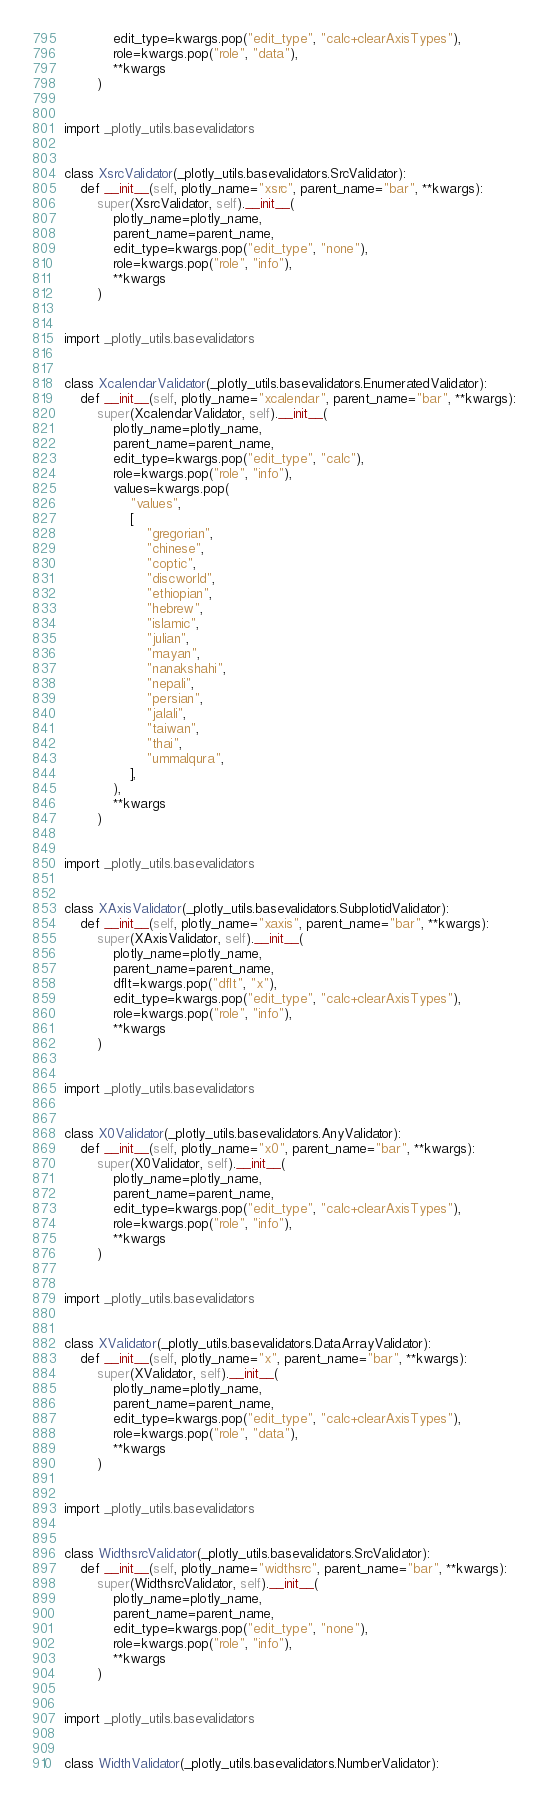Convert code to text. <code><loc_0><loc_0><loc_500><loc_500><_Python_>            edit_type=kwargs.pop("edit_type", "calc+clearAxisTypes"),
            role=kwargs.pop("role", "data"),
            **kwargs
        )


import _plotly_utils.basevalidators


class XsrcValidator(_plotly_utils.basevalidators.SrcValidator):
    def __init__(self, plotly_name="xsrc", parent_name="bar", **kwargs):
        super(XsrcValidator, self).__init__(
            plotly_name=plotly_name,
            parent_name=parent_name,
            edit_type=kwargs.pop("edit_type", "none"),
            role=kwargs.pop("role", "info"),
            **kwargs
        )


import _plotly_utils.basevalidators


class XcalendarValidator(_plotly_utils.basevalidators.EnumeratedValidator):
    def __init__(self, plotly_name="xcalendar", parent_name="bar", **kwargs):
        super(XcalendarValidator, self).__init__(
            plotly_name=plotly_name,
            parent_name=parent_name,
            edit_type=kwargs.pop("edit_type", "calc"),
            role=kwargs.pop("role", "info"),
            values=kwargs.pop(
                "values",
                [
                    "gregorian",
                    "chinese",
                    "coptic",
                    "discworld",
                    "ethiopian",
                    "hebrew",
                    "islamic",
                    "julian",
                    "mayan",
                    "nanakshahi",
                    "nepali",
                    "persian",
                    "jalali",
                    "taiwan",
                    "thai",
                    "ummalqura",
                ],
            ),
            **kwargs
        )


import _plotly_utils.basevalidators


class XAxisValidator(_plotly_utils.basevalidators.SubplotidValidator):
    def __init__(self, plotly_name="xaxis", parent_name="bar", **kwargs):
        super(XAxisValidator, self).__init__(
            plotly_name=plotly_name,
            parent_name=parent_name,
            dflt=kwargs.pop("dflt", "x"),
            edit_type=kwargs.pop("edit_type", "calc+clearAxisTypes"),
            role=kwargs.pop("role", "info"),
            **kwargs
        )


import _plotly_utils.basevalidators


class X0Validator(_plotly_utils.basevalidators.AnyValidator):
    def __init__(self, plotly_name="x0", parent_name="bar", **kwargs):
        super(X0Validator, self).__init__(
            plotly_name=plotly_name,
            parent_name=parent_name,
            edit_type=kwargs.pop("edit_type", "calc+clearAxisTypes"),
            role=kwargs.pop("role", "info"),
            **kwargs
        )


import _plotly_utils.basevalidators


class XValidator(_plotly_utils.basevalidators.DataArrayValidator):
    def __init__(self, plotly_name="x", parent_name="bar", **kwargs):
        super(XValidator, self).__init__(
            plotly_name=plotly_name,
            parent_name=parent_name,
            edit_type=kwargs.pop("edit_type", "calc+clearAxisTypes"),
            role=kwargs.pop("role", "data"),
            **kwargs
        )


import _plotly_utils.basevalidators


class WidthsrcValidator(_plotly_utils.basevalidators.SrcValidator):
    def __init__(self, plotly_name="widthsrc", parent_name="bar", **kwargs):
        super(WidthsrcValidator, self).__init__(
            plotly_name=plotly_name,
            parent_name=parent_name,
            edit_type=kwargs.pop("edit_type", "none"),
            role=kwargs.pop("role", "info"),
            **kwargs
        )


import _plotly_utils.basevalidators


class WidthValidator(_plotly_utils.basevalidators.NumberValidator):</code> 